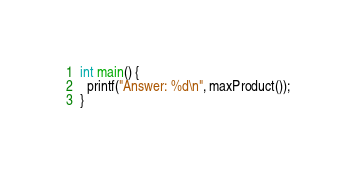Convert code to text. <code><loc_0><loc_0><loc_500><loc_500><_C_>int main() {
  printf("Answer: %d\n", maxProduct());
}
</code> 